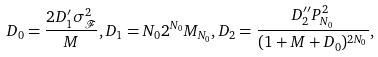Convert formula to latex. <formula><loc_0><loc_0><loc_500><loc_500>D _ { 0 } = \frac { 2 D _ { 1 } ^ { \prime } \sigma _ { \mathcal { F } } ^ { 2 } } { M } , D _ { 1 } = N _ { 0 } 2 ^ { N _ { 0 } } M _ { N _ { 0 } } , D _ { 2 } = \frac { D _ { 2 } ^ { \prime \prime } P _ { N _ { 0 } } ^ { 2 } } { ( 1 + M + D _ { 0 } ) ^ { 2 N _ { 0 } } } ,</formula> 